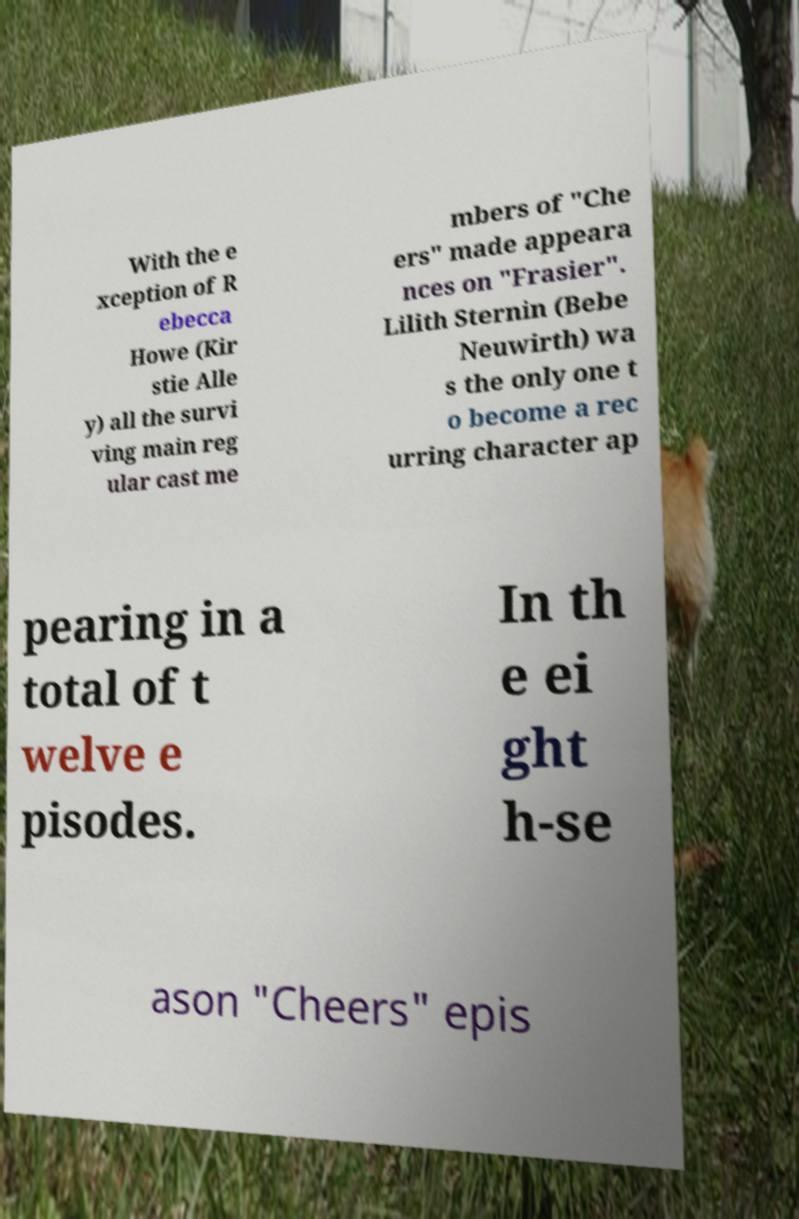Could you assist in decoding the text presented in this image and type it out clearly? With the e xception of R ebecca Howe (Kir stie Alle y) all the survi ving main reg ular cast me mbers of "Che ers" made appeara nces on "Frasier". Lilith Sternin (Bebe Neuwirth) wa s the only one t o become a rec urring character ap pearing in a total of t welve e pisodes. In th e ei ght h-se ason "Cheers" epis 